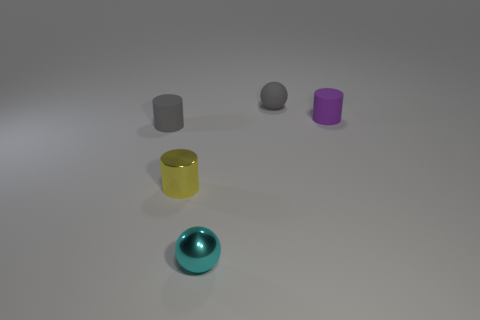What is the color of the metallic thing that is the same shape as the tiny purple rubber thing?
Provide a short and direct response. Yellow. Are there any gray rubber cylinders to the left of the rubber thing to the right of the sphere that is behind the purple cylinder?
Your response must be concise. Yes. Does the purple matte thing have the same shape as the cyan thing?
Offer a terse response. No. Is the number of rubber balls right of the tiny rubber ball less than the number of cyan metal balls?
Offer a terse response. Yes. What is the color of the tiny ball that is on the left side of the gray matte thing right of the gray thing that is left of the gray sphere?
Make the answer very short. Cyan. What number of rubber things are either tiny purple objects or small gray balls?
Keep it short and to the point. 2. Is the size of the purple cylinder the same as the cyan metal sphere?
Offer a very short reply. Yes. Is the number of small purple rubber cylinders in front of the tiny cyan thing less than the number of yellow objects that are right of the yellow metallic thing?
Offer a terse response. No. Is there anything else that has the same size as the cyan metal sphere?
Make the answer very short. Yes. What size is the cyan thing?
Provide a succinct answer. Small. 